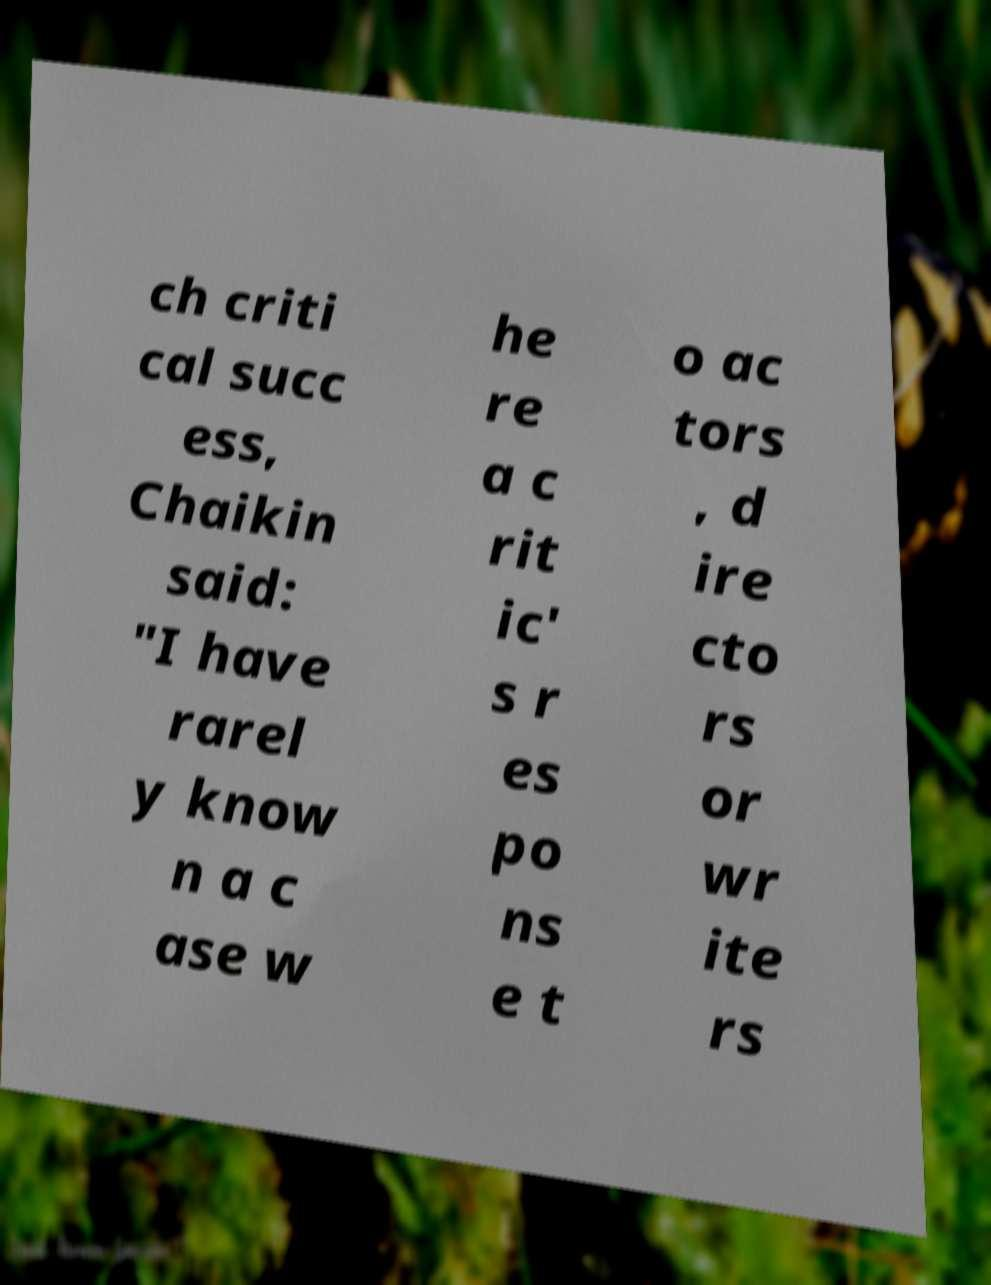What messages or text are displayed in this image? I need them in a readable, typed format. ch criti cal succ ess, Chaikin said: "I have rarel y know n a c ase w he re a c rit ic' s r es po ns e t o ac tors , d ire cto rs or wr ite rs 